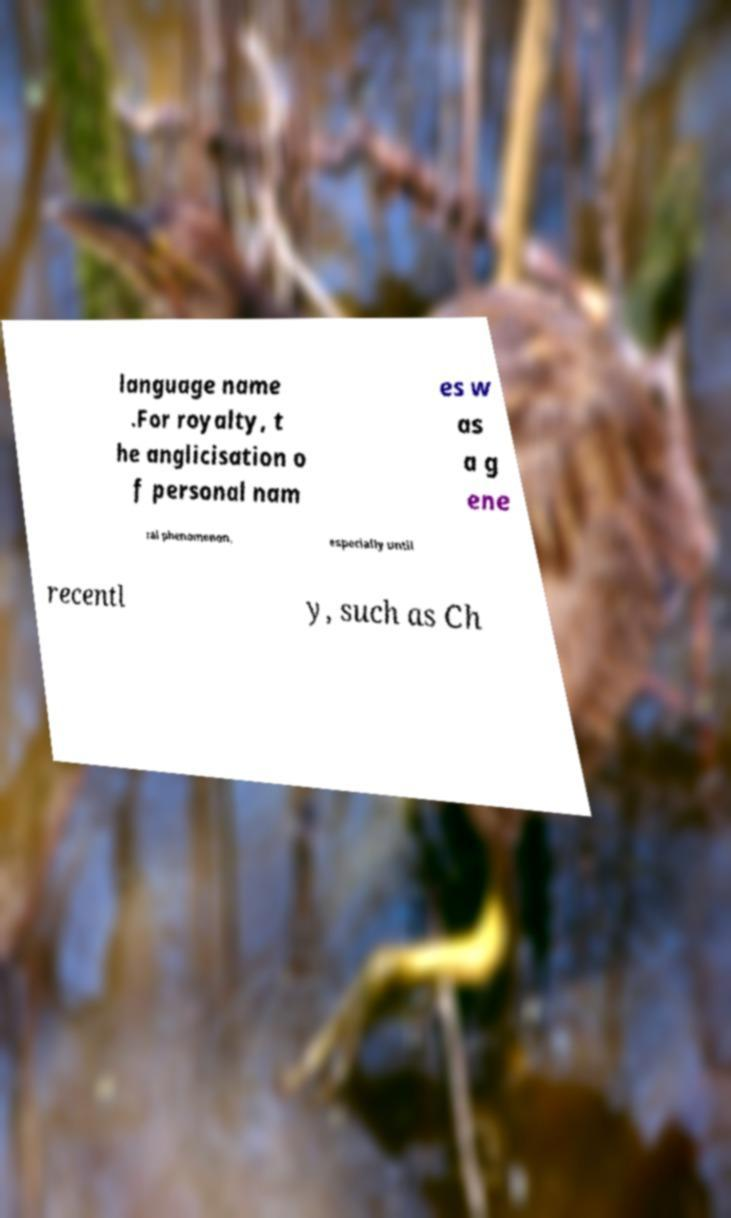I need the written content from this picture converted into text. Can you do that? language name .For royalty, t he anglicisation o f personal nam es w as a g ene ral phenomenon, especially until recentl y, such as Ch 